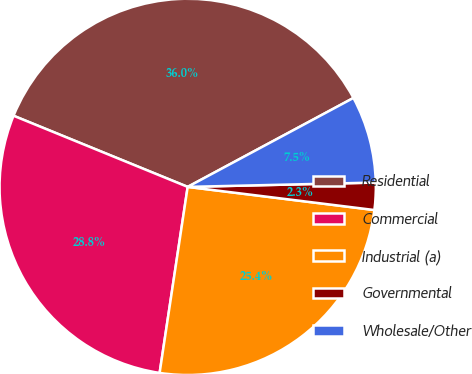Convert chart to OTSL. <chart><loc_0><loc_0><loc_500><loc_500><pie_chart><fcel>Residential<fcel>Commercial<fcel>Industrial (a)<fcel>Governmental<fcel>Wholesale/Other<nl><fcel>35.99%<fcel>28.79%<fcel>25.42%<fcel>2.33%<fcel>7.47%<nl></chart> 